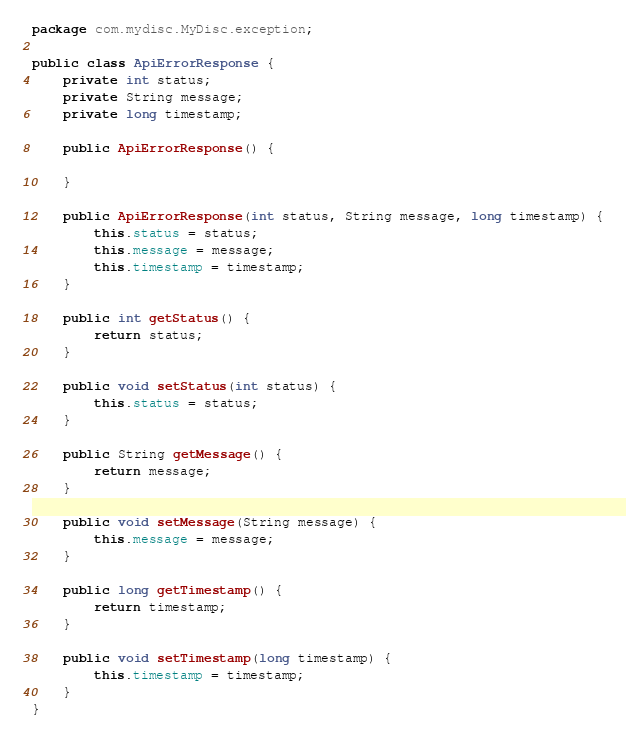Convert code to text. <code><loc_0><loc_0><loc_500><loc_500><_Java_>package com.mydisc.MyDisc.exception;

public class ApiErrorResponse {
    private int status;
    private String message;
    private long timestamp;

    public ApiErrorResponse() {

    }

    public ApiErrorResponse(int status, String message, long timestamp) {
        this.status = status;
        this.message = message;
        this.timestamp = timestamp;
    }

    public int getStatus() {
        return status;
    }

    public void setStatus(int status) {
        this.status = status;
    }

    public String getMessage() {
        return message;
    }

    public void setMessage(String message) {
        this.message = message;
    }

    public long getTimestamp() {
        return timestamp;
    }

    public void setTimestamp(long timestamp) {
        this.timestamp = timestamp;
    }
}
</code> 